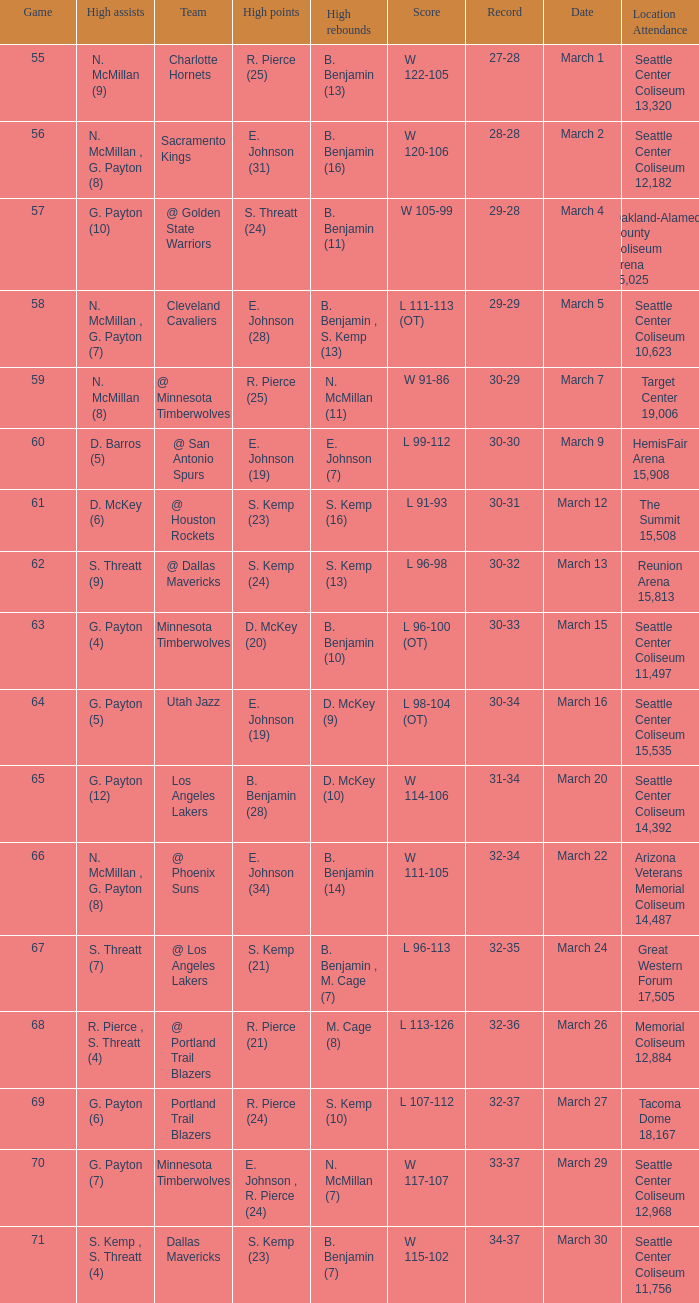Would you be able to parse every entry in this table? {'header': ['Game', 'High assists', 'Team', 'High points', 'High rebounds', 'Score', 'Record', 'Date', 'Location Attendance'], 'rows': [['55', 'N. McMillan (9)', 'Charlotte Hornets', 'R. Pierce (25)', 'B. Benjamin (13)', 'W 122-105', '27-28', 'March 1', 'Seattle Center Coliseum 13,320'], ['56', 'N. McMillan , G. Payton (8)', 'Sacramento Kings', 'E. Johnson (31)', 'B. Benjamin (16)', 'W 120-106', '28-28', 'March 2', 'Seattle Center Coliseum 12,182'], ['57', 'G. Payton (10)', '@ Golden State Warriors', 'S. Threatt (24)', 'B. Benjamin (11)', 'W 105-99', '29-28', 'March 4', 'Oakland-Alameda County Coliseum Arena 15,025'], ['58', 'N. McMillan , G. Payton (7)', 'Cleveland Cavaliers', 'E. Johnson (28)', 'B. Benjamin , S. Kemp (13)', 'L 111-113 (OT)', '29-29', 'March 5', 'Seattle Center Coliseum 10,623'], ['59', 'N. McMillan (8)', '@ Minnesota Timberwolves', 'R. Pierce (25)', 'N. McMillan (11)', 'W 91-86', '30-29', 'March 7', 'Target Center 19,006'], ['60', 'D. Barros (5)', '@ San Antonio Spurs', 'E. Johnson (19)', 'E. Johnson (7)', 'L 99-112', '30-30', 'March 9', 'HemisFair Arena 15,908'], ['61', 'D. McKey (6)', '@ Houston Rockets', 'S. Kemp (23)', 'S. Kemp (16)', 'L 91-93', '30-31', 'March 12', 'The Summit 15,508'], ['62', 'S. Threatt (9)', '@ Dallas Mavericks', 'S. Kemp (24)', 'S. Kemp (13)', 'L 96-98', '30-32', 'March 13', 'Reunion Arena 15,813'], ['63', 'G. Payton (4)', 'Minnesota Timberwolves', 'D. McKey (20)', 'B. Benjamin (10)', 'L 96-100 (OT)', '30-33', 'March 15', 'Seattle Center Coliseum 11,497'], ['64', 'G. Payton (5)', 'Utah Jazz', 'E. Johnson (19)', 'D. McKey (9)', 'L 98-104 (OT)', '30-34', 'March 16', 'Seattle Center Coliseum 15,535'], ['65', 'G. Payton (12)', 'Los Angeles Lakers', 'B. Benjamin (28)', 'D. McKey (10)', 'W 114-106', '31-34', 'March 20', 'Seattle Center Coliseum 14,392'], ['66', 'N. McMillan , G. Payton (8)', '@ Phoenix Suns', 'E. Johnson (34)', 'B. Benjamin (14)', 'W 111-105', '32-34', 'March 22', 'Arizona Veterans Memorial Coliseum 14,487'], ['67', 'S. Threatt (7)', '@ Los Angeles Lakers', 'S. Kemp (21)', 'B. Benjamin , M. Cage (7)', 'L 96-113', '32-35', 'March 24', 'Great Western Forum 17,505'], ['68', 'R. Pierce , S. Threatt (4)', '@ Portland Trail Blazers', 'R. Pierce (21)', 'M. Cage (8)', 'L 113-126', '32-36', 'March 26', 'Memorial Coliseum 12,884'], ['69', 'G. Payton (6)', 'Portland Trail Blazers', 'R. Pierce (24)', 'S. Kemp (10)', 'L 107-112', '32-37', 'March 27', 'Tacoma Dome 18,167'], ['70', 'G. Payton (7)', 'Minnesota Timberwolves', 'E. Johnson , R. Pierce (24)', 'N. McMillan (7)', 'W 117-107', '33-37', 'March 29', 'Seattle Center Coliseum 12,968'], ['71', 'S. Kemp , S. Threatt (4)', 'Dallas Mavericks', 'S. Kemp (23)', 'B. Benjamin (7)', 'W 115-102', '34-37', 'March 30', 'Seattle Center Coliseum 11,756']]} Which Game has High assists of s. threatt (9)? 62.0. 